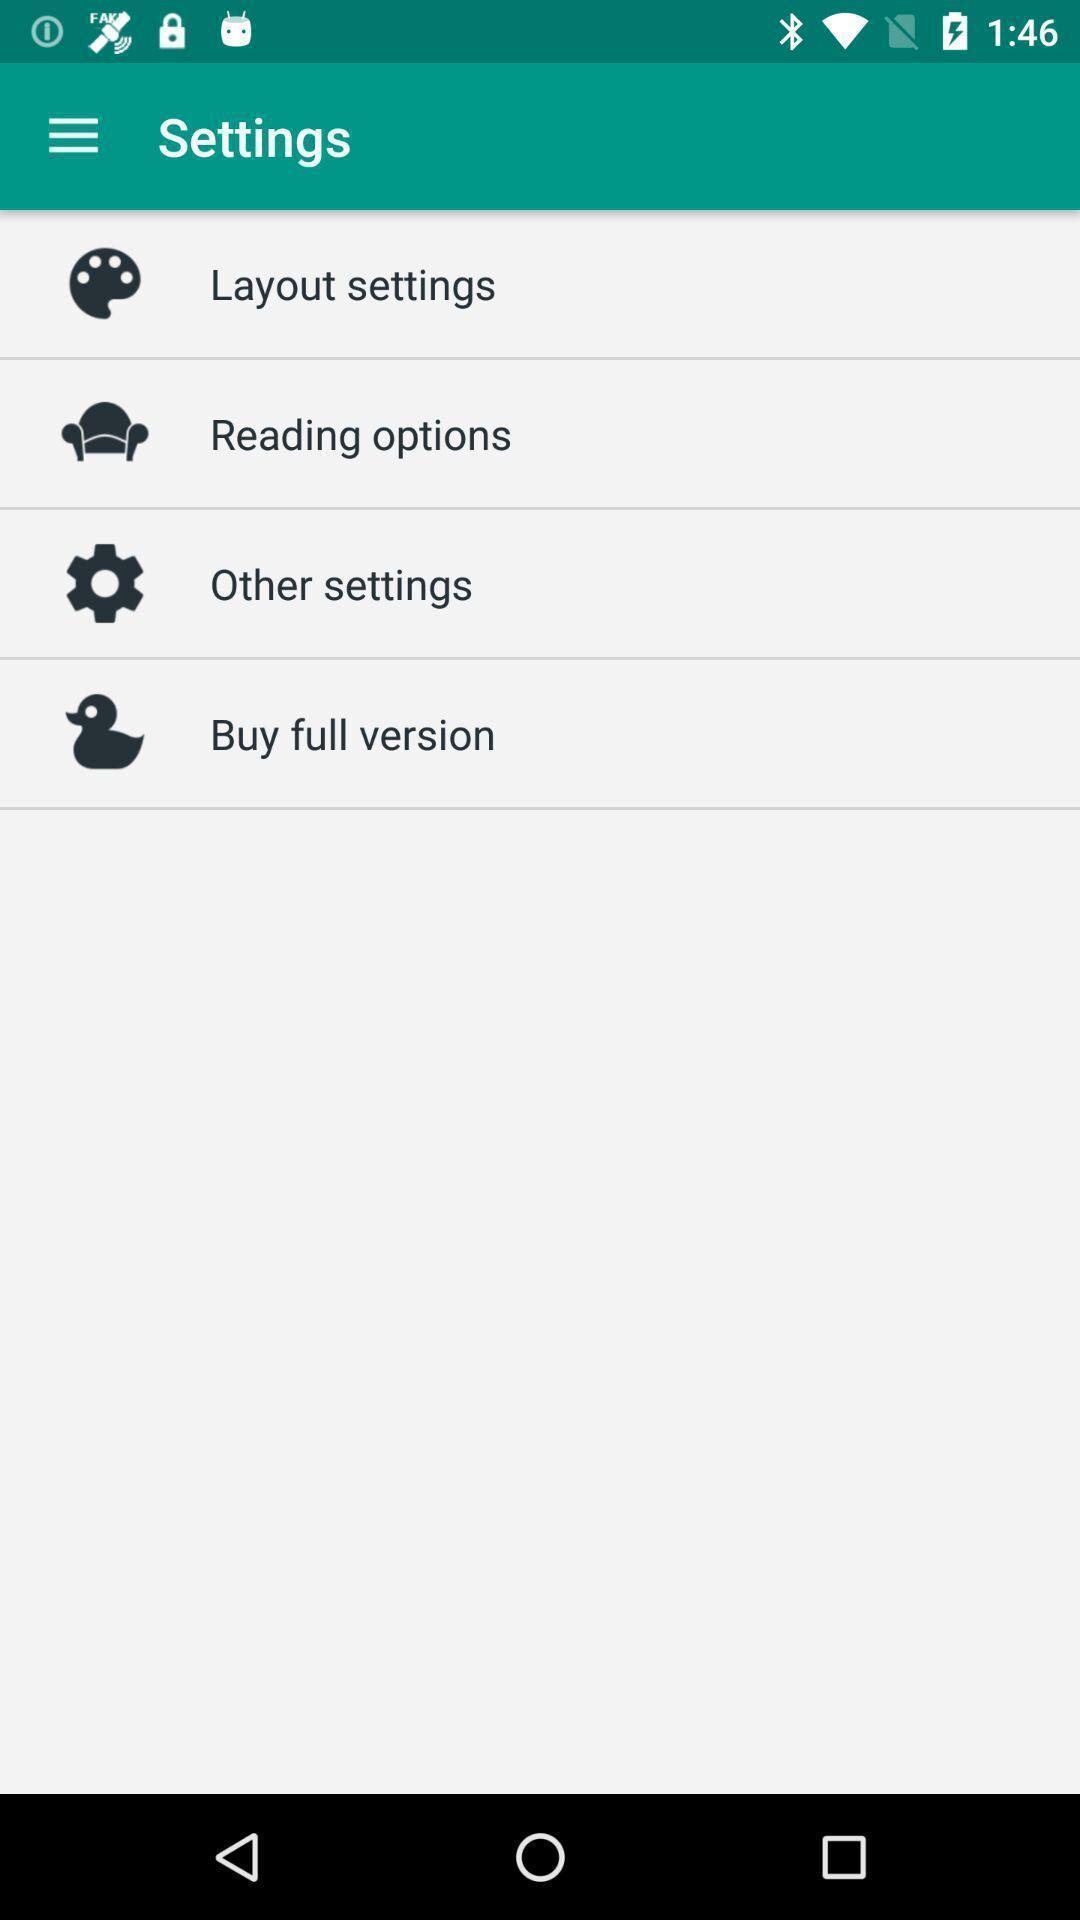Tell me about the visual elements in this screen capture. Various types of settings are displaying in the page. 